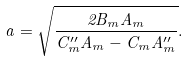<formula> <loc_0><loc_0><loc_500><loc_500>a = \sqrt { \frac { 2 B _ { m } A _ { m } } { C ^ { \prime \prime } _ { m } A _ { m } - C _ { m } A ^ { \prime \prime } _ { m } } } .</formula> 